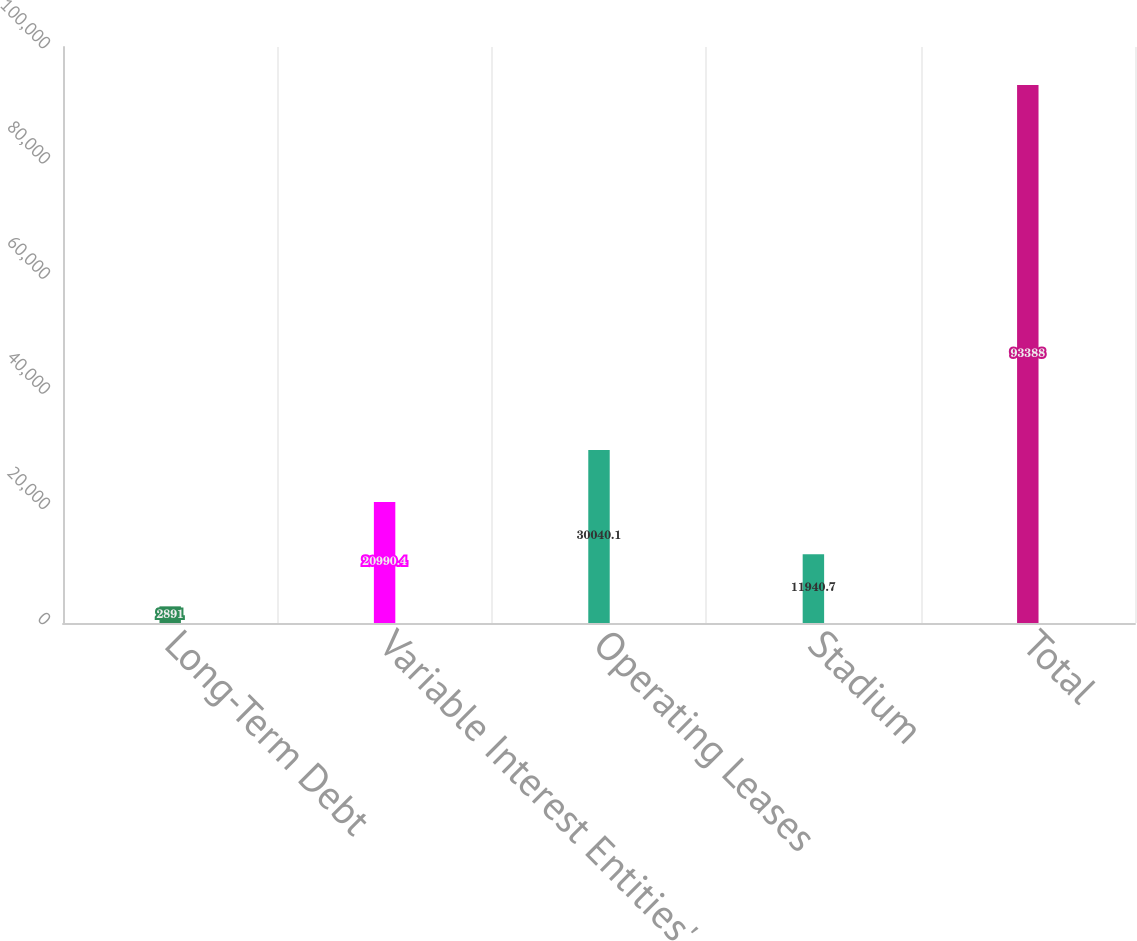Convert chart to OTSL. <chart><loc_0><loc_0><loc_500><loc_500><bar_chart><fcel>Long-Term Debt<fcel>Variable Interest Entities'<fcel>Operating Leases<fcel>Stadium<fcel>Total<nl><fcel>2891<fcel>20990.4<fcel>30040.1<fcel>11940.7<fcel>93388<nl></chart> 